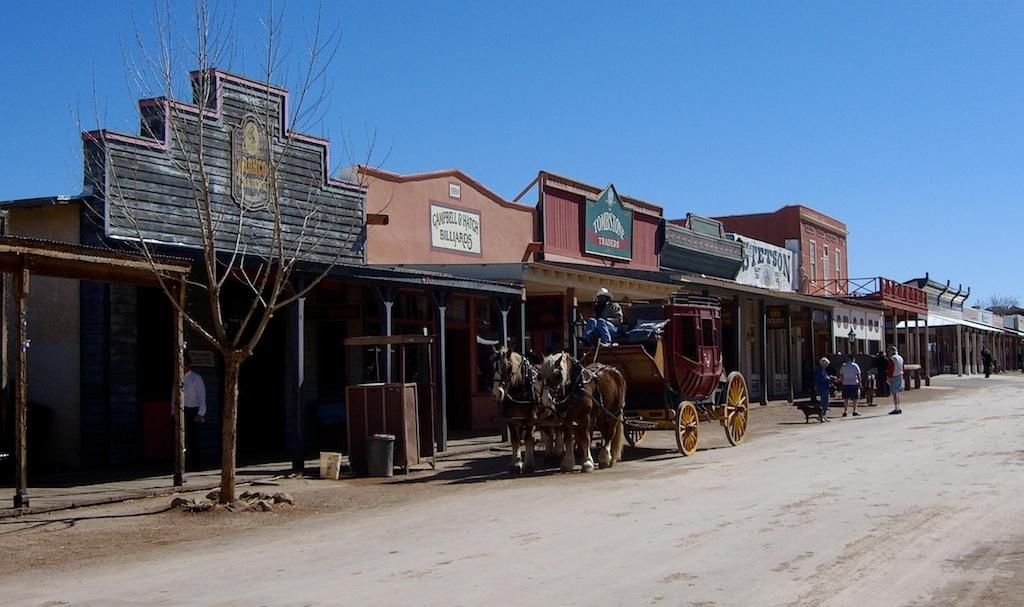What type of establishments can be seen in the image? There are stores in the image. What natural element is present in the image? There is a tree in the image. What animal is in the image? There is a horse in the image. What object is being used to transport goods or items in the image? There is a cart in the image. Are there any human beings present in the image? Yes, there are people in the image. What is the color of the sky in the image? The sky is blue in the image. Can you tell me how many ants are crawling on the horse in the image? There are no ants present in the image, and therefore no such activity can be observed. How much money is being exchanged between the people in the image? There is no mention of money or any financial transaction in the image. 